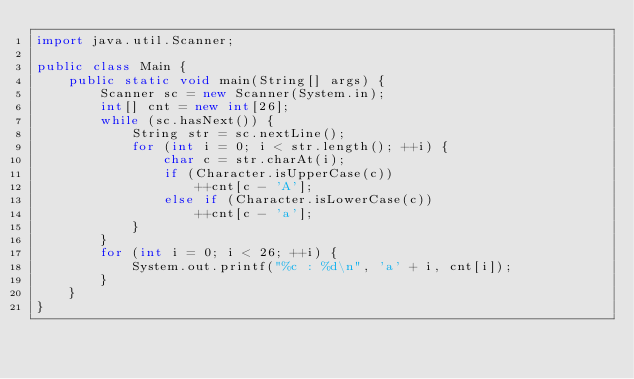<code> <loc_0><loc_0><loc_500><loc_500><_Java_>import java.util.Scanner;

public class Main {
	public static void main(String[] args) {
		Scanner sc = new Scanner(System.in);
		int[] cnt = new int[26];
		while (sc.hasNext()) {
			String str = sc.nextLine();
			for (int i = 0; i < str.length(); ++i) {
				char c = str.charAt(i);
				if (Character.isUpperCase(c))
					++cnt[c - 'A'];
				else if (Character.isLowerCase(c))
					++cnt[c - 'a'];
			}
		}
		for (int i = 0; i < 26; ++i) {
			System.out.printf("%c : %d\n", 'a' + i, cnt[i]);
		}
	}
}
</code> 